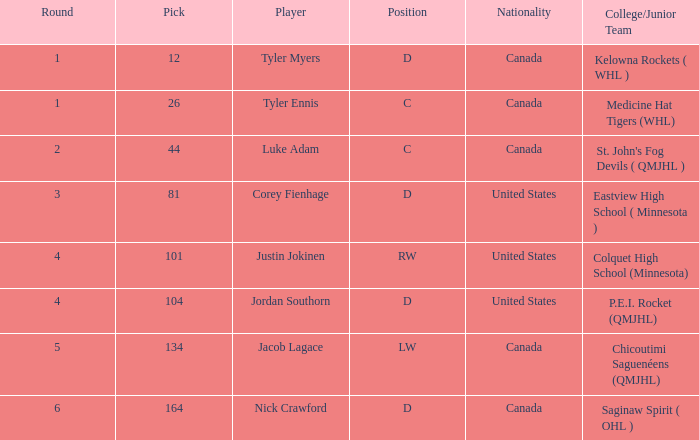For corey fienhage, who has a pick number less than 104, which nationality does he hold? United States. 